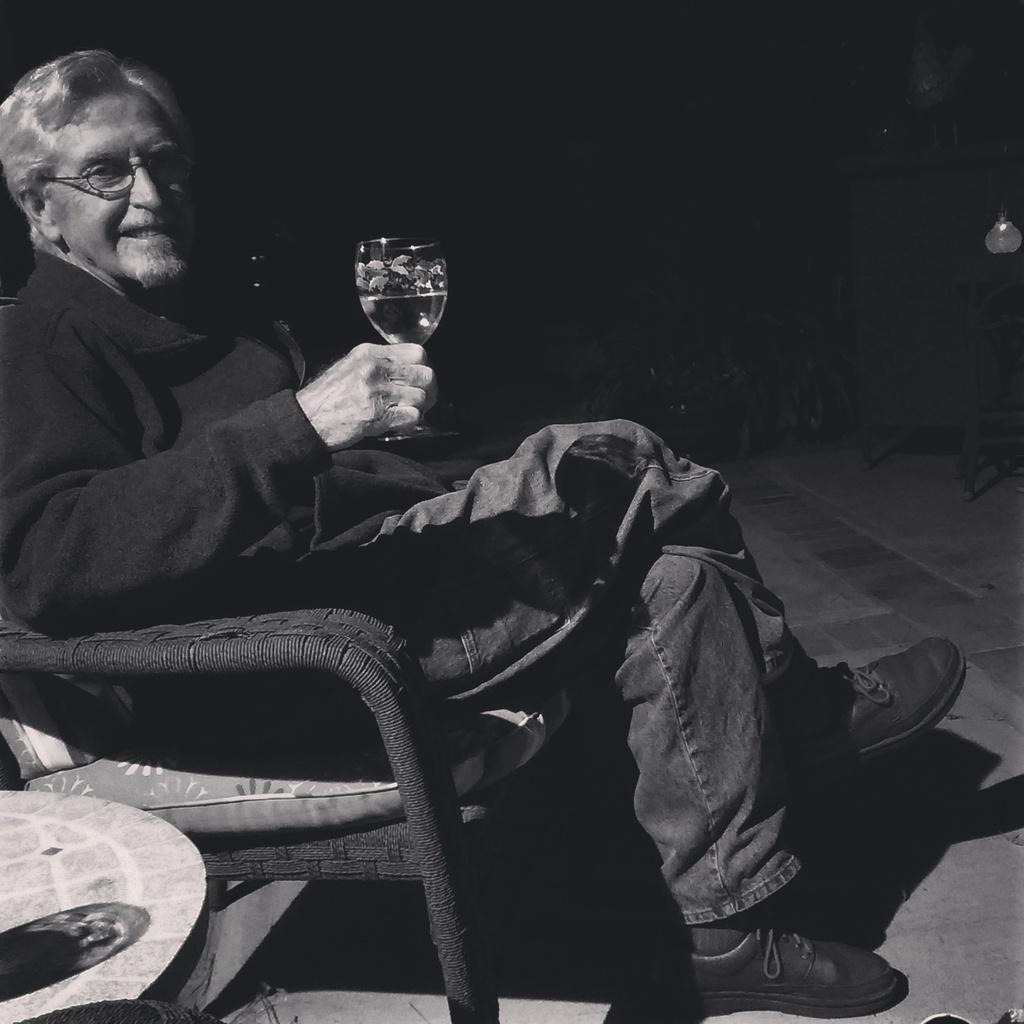Who is present in the image? There is a man in the picture. What is the man doing in the image? The man is sitting on a sofa. What is the man holding in the image? The man is holding a wine glass. What is the man wearing in the image? The man is wearing a coat. What expression does the man have in the image? The man is smiling. What is located beside the man in the image? There is a table beside the man. What type of cactus can be seen growing on the table beside the man? There is no cactus present on the table beside the man in the image. What is the man using to store his arrows in the image? The man is not using a quiver to store arrows in the image, as there is no mention of arrows or a quiver in the provided facts. 